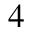<formula> <loc_0><loc_0><loc_500><loc_500>_ { 4 }</formula> 